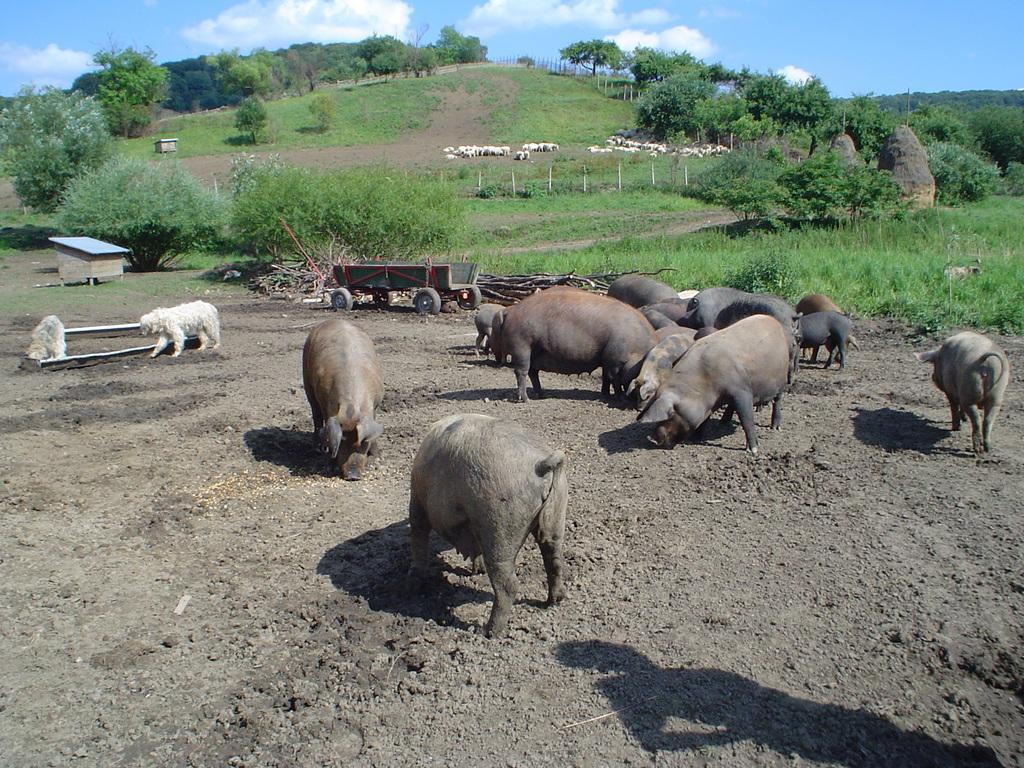How would you summarize this image in a sentence or two? In this image we can see some animals, trees and other objects. In the background of the image there are trees, animals, grass and other objects. At the top of the image there is the sky. At the bottom of the image there is the ground. On the right side bottom of the image there is a shadow. 